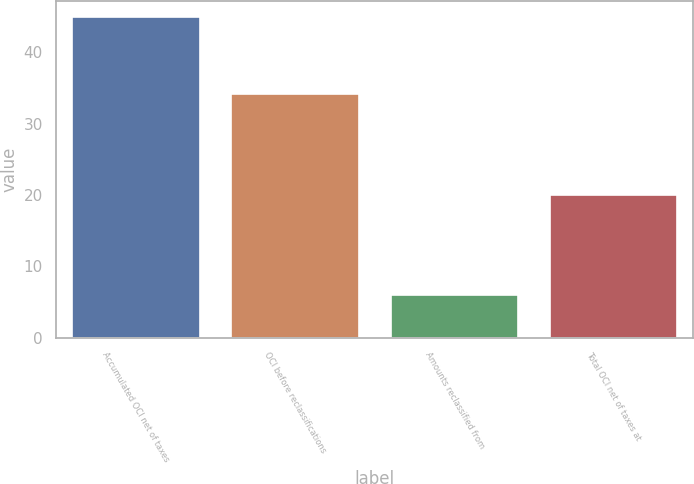<chart> <loc_0><loc_0><loc_500><loc_500><bar_chart><fcel>Accumulated OCI net of taxes<fcel>OCI before reclassifications<fcel>Amounts reclassified from<fcel>Total OCI net of taxes at<nl><fcel>45<fcel>34.1<fcel>6<fcel>20<nl></chart> 